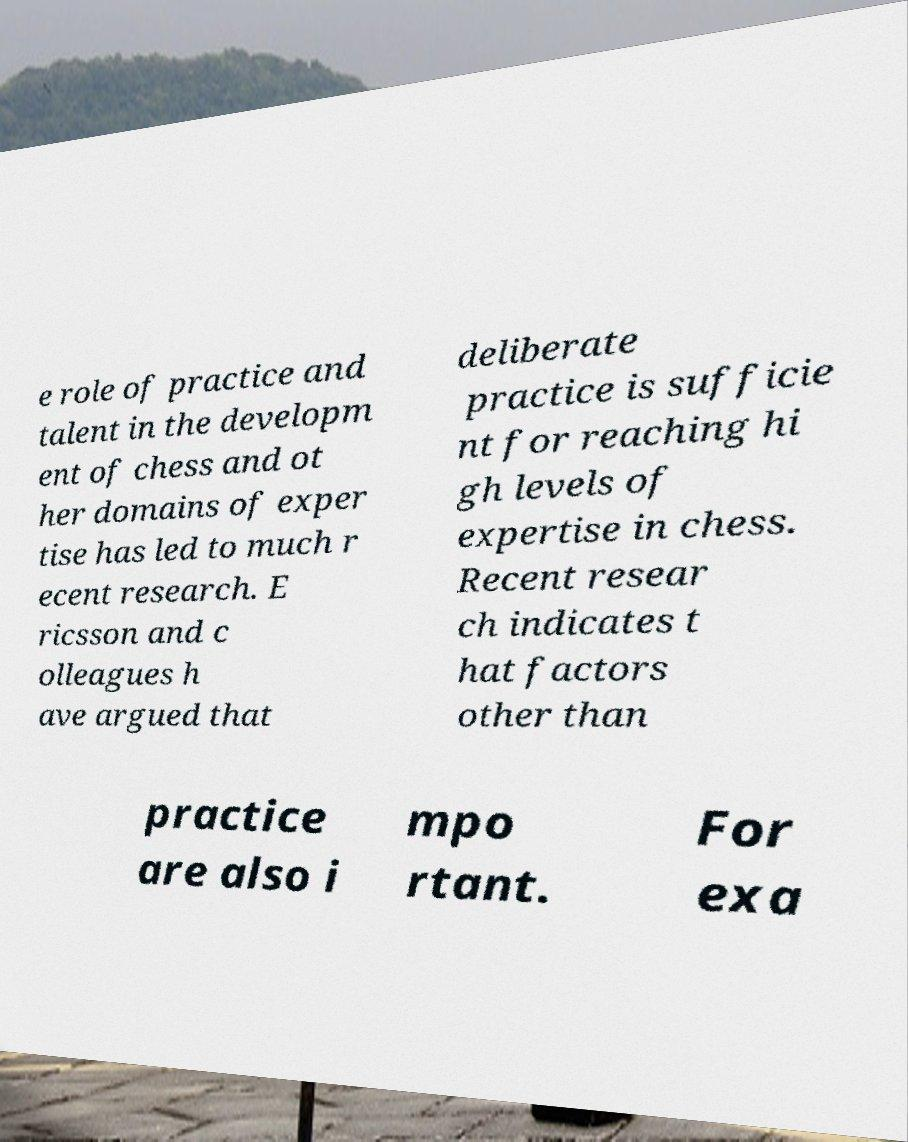What messages or text are displayed in this image? I need them in a readable, typed format. e role of practice and talent in the developm ent of chess and ot her domains of exper tise has led to much r ecent research. E ricsson and c olleagues h ave argued that deliberate practice is sufficie nt for reaching hi gh levels of expertise in chess. Recent resear ch indicates t hat factors other than practice are also i mpo rtant. For exa 